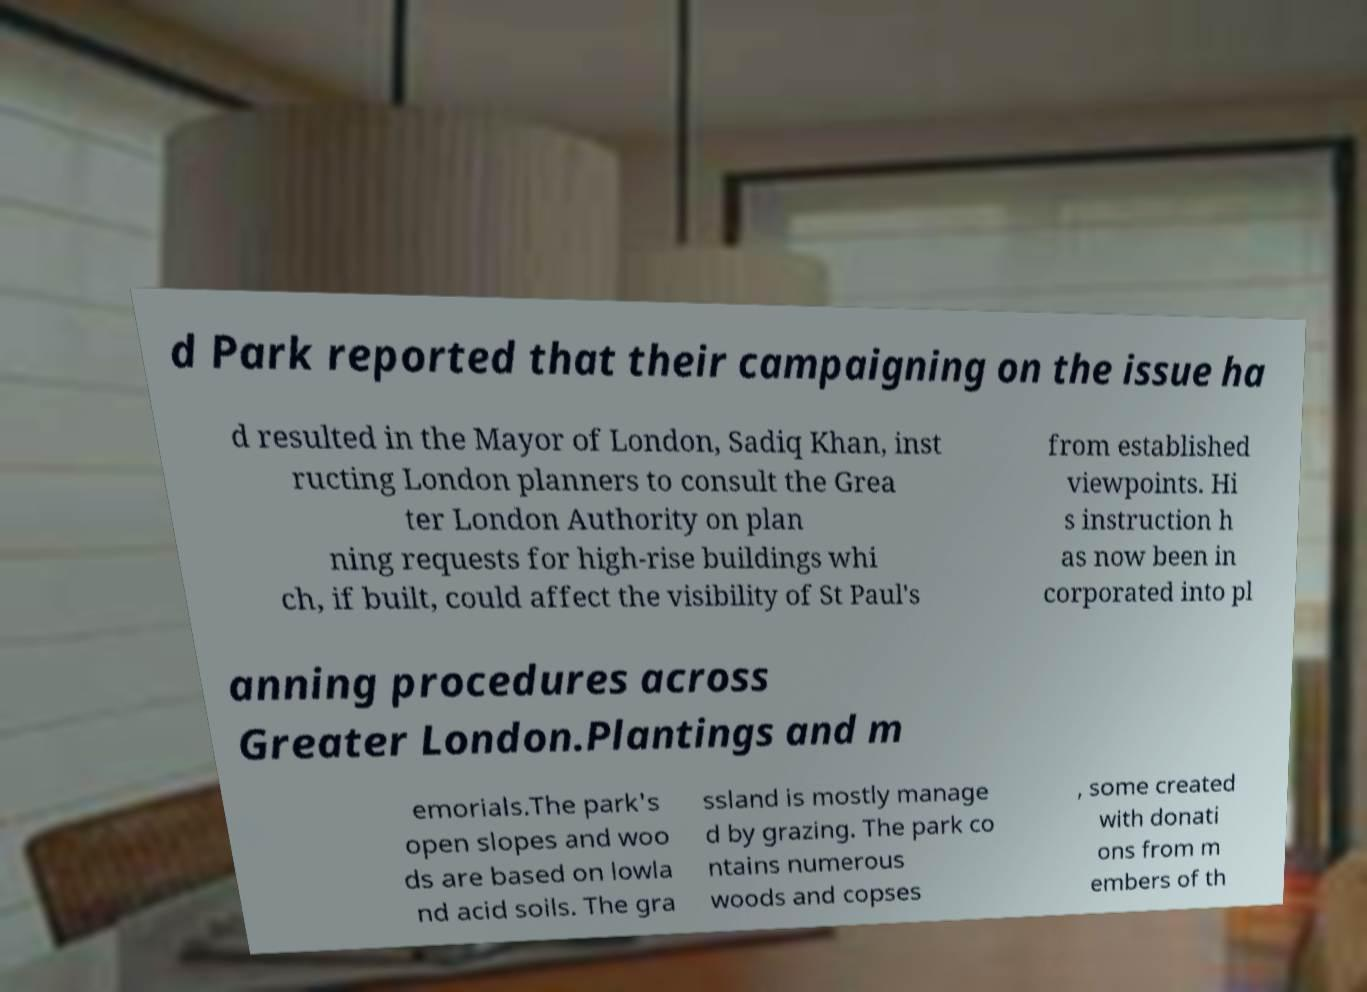Can you accurately transcribe the text from the provided image for me? d Park reported that their campaigning on the issue ha d resulted in the Mayor of London, Sadiq Khan, inst ructing London planners to consult the Grea ter London Authority on plan ning requests for high-rise buildings whi ch, if built, could affect the visibility of St Paul's from established viewpoints. Hi s instruction h as now been in corporated into pl anning procedures across Greater London.Plantings and m emorials.The park's open slopes and woo ds are based on lowla nd acid soils. The gra ssland is mostly manage d by grazing. The park co ntains numerous woods and copses , some created with donati ons from m embers of th 